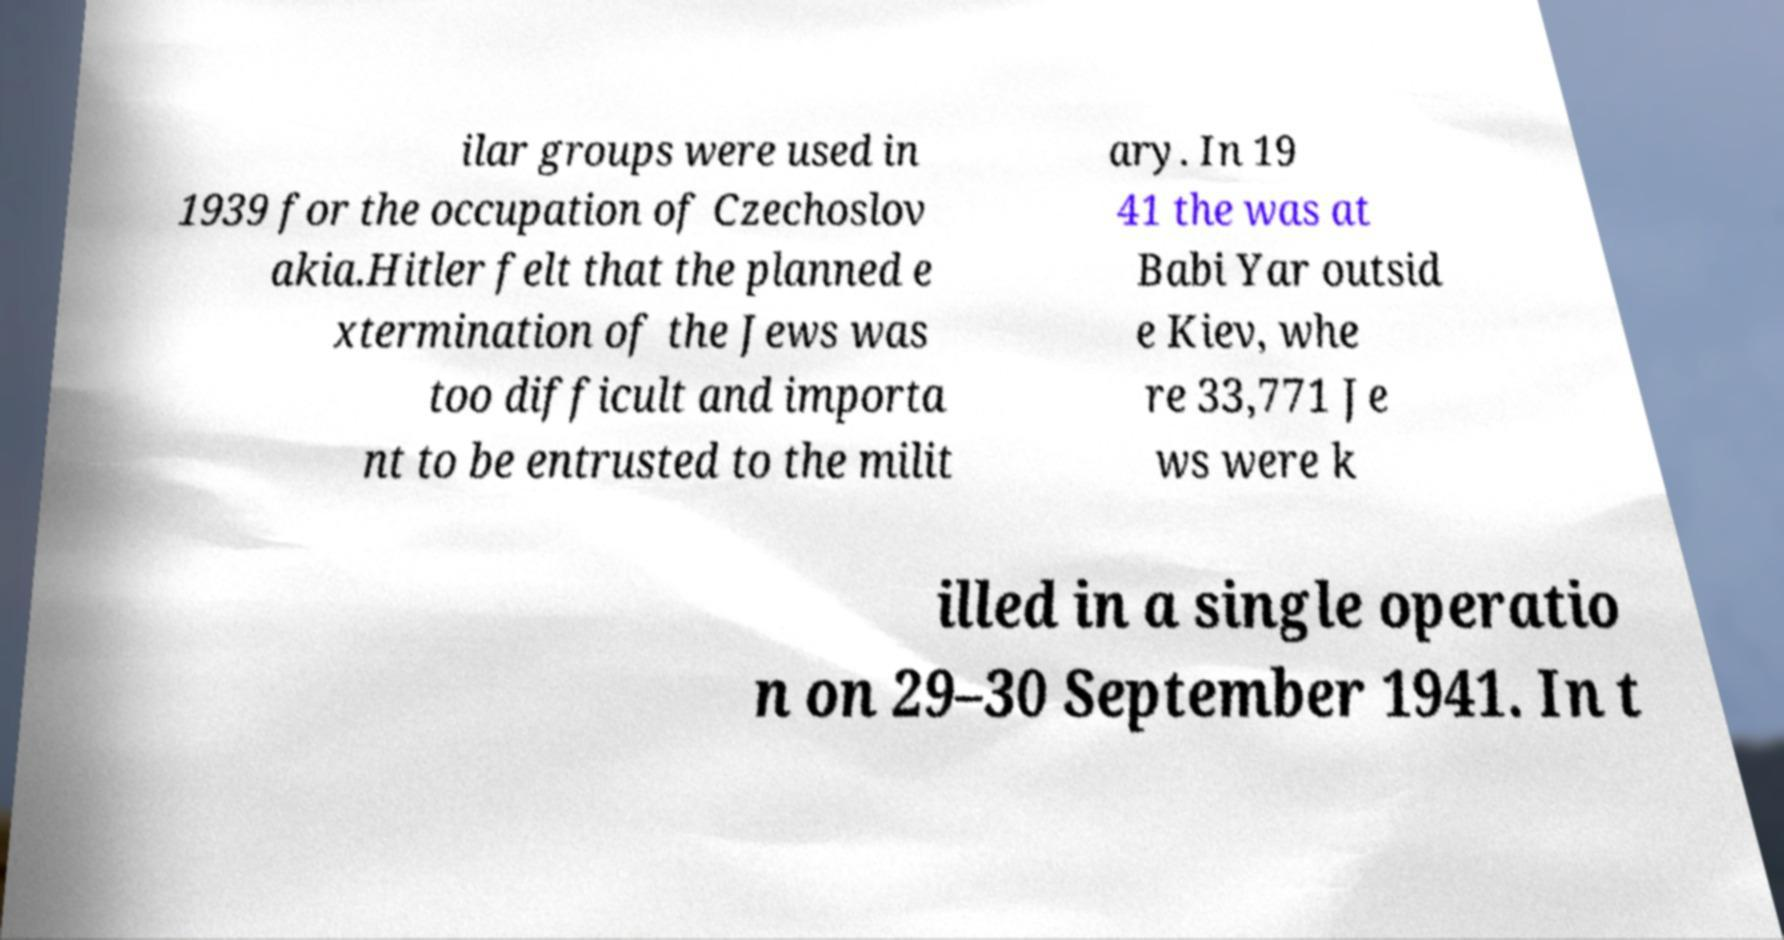Please read and relay the text visible in this image. What does it say? ilar groups were used in 1939 for the occupation of Czechoslov akia.Hitler felt that the planned e xtermination of the Jews was too difficult and importa nt to be entrusted to the milit ary. In 19 41 the was at Babi Yar outsid e Kiev, whe re 33,771 Je ws were k illed in a single operatio n on 29–30 September 1941. In t 